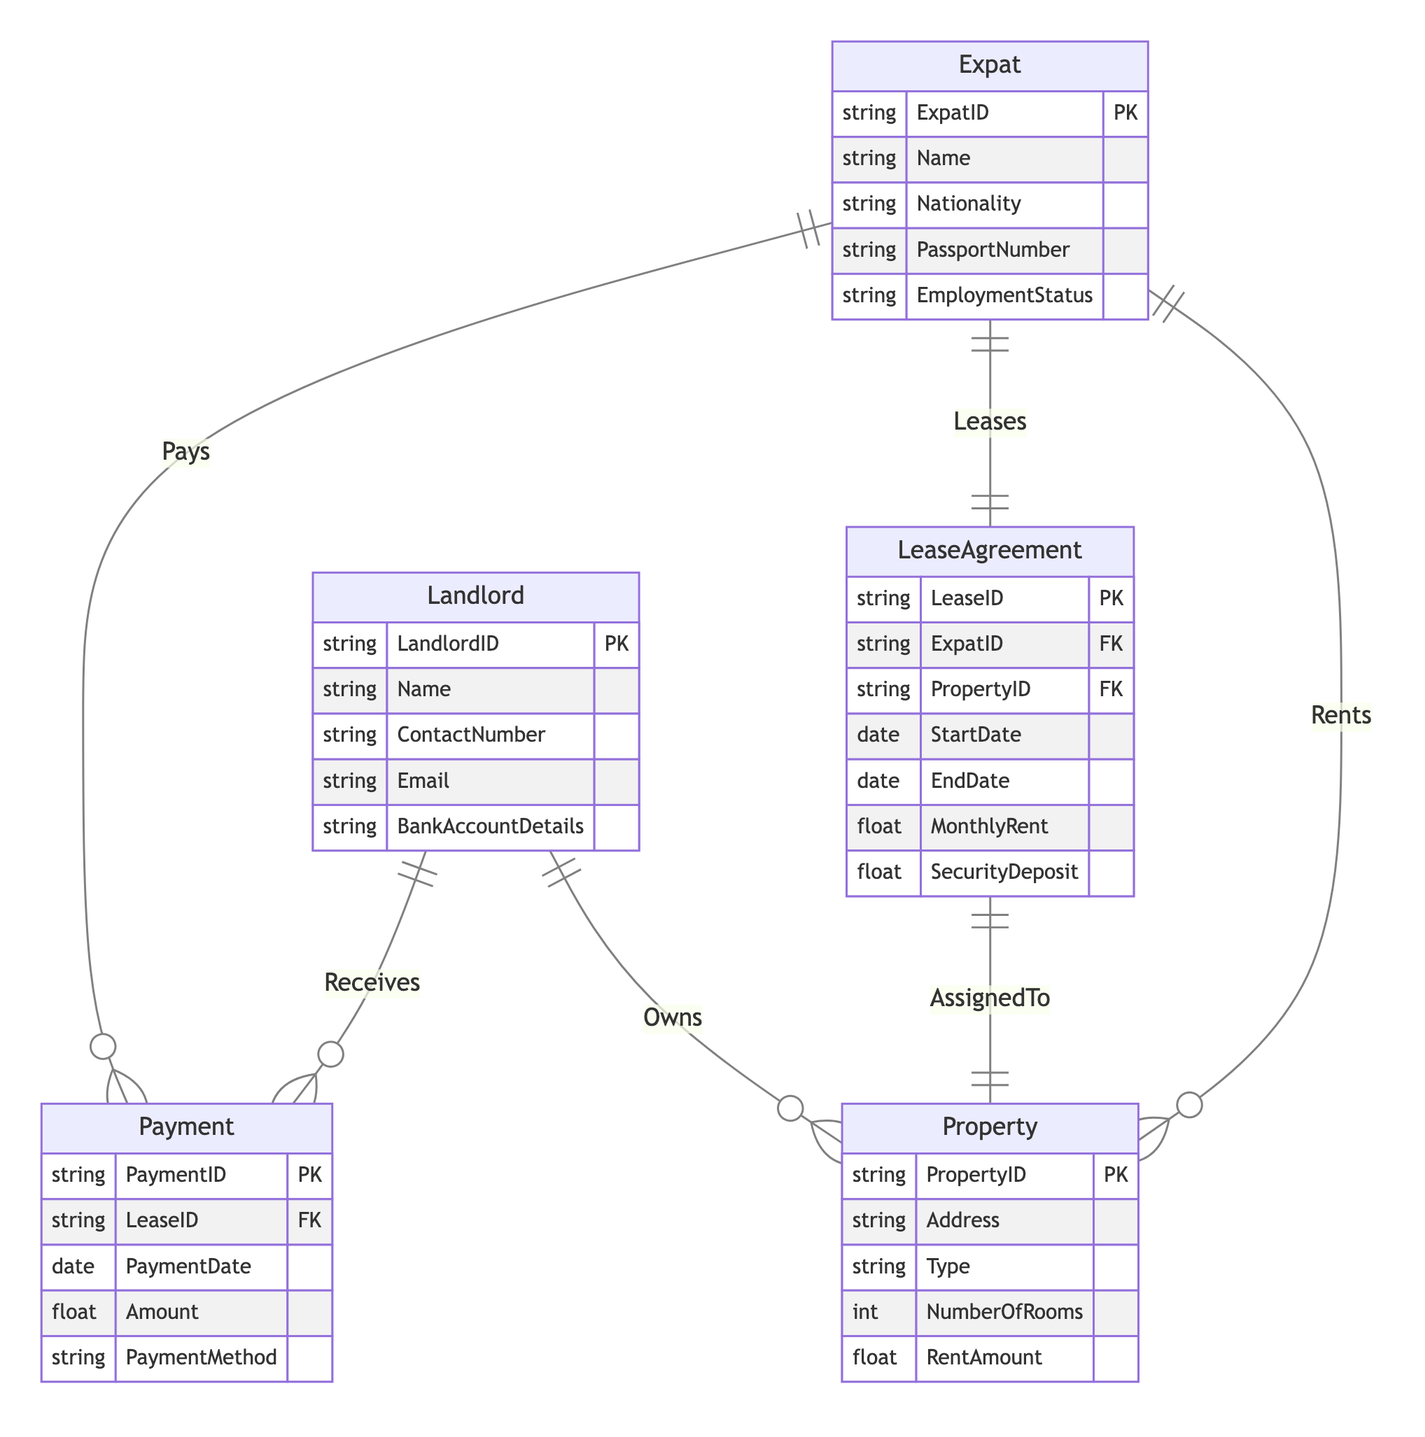What entities are involved in rental agreements? The diagram contains five entities that are directly involved in rental agreements: Expat, Property, LeaseAgreement, Landlord, and Payment.
Answer: Expat, Property, LeaseAgreement, Landlord, Payment How many relationships exist in the diagram? There are six relationships defined in the diagram: Rents, Leases, Owns, Receives, AssignedTo, and Pays.
Answer: Six Which entity has the attribute "SecurityDeposit"? The "SecurityDeposit" attribute is found in the LeaseAgreement entity, which relates to the lease terms between the expat and the landlord.
Answer: LeaseAgreement What kind of relationship exists between Expat and LeaseAgreement? The relationship between Expat and LeaseAgreement is a One-to-One relationship, meaning each expat can have only one lease agreement at a time.
Answer: One-to-One How many properties can a landlord own? A landlord can own multiple properties, as indicated by the One-to-Many relationship between Landlord and Property. This means one landlord can have many properties under their ownership.
Answer: Many Which payment methods can an expat use? The diagram does not specify the exact payment methods but indicates that an Expat pays for the LeaseAgreement. The specific types of payment methods would typically be defined within the Payment entity's "PaymentMethod" attribute.
Answer: Various (not specified) Who receives payment for the lease? The landlord receives payment for the lease, as indicated by the Receives relationship connecting the Landlord and Payment entities.
Answer: Landlord What is the maximum number of rooms a property can have? The diagram does not specify a maximum number of rooms; however, it does include "NumberOfRooms" as an attribute of the Property entity, suggesting that this information can vary based on the properties available.
Answer: Not specified What type of entity is "Payment"? "Payment" is an entity that records details related to lease payments, such as the amount paid, payment date, and payment method.
Answer: Entity 